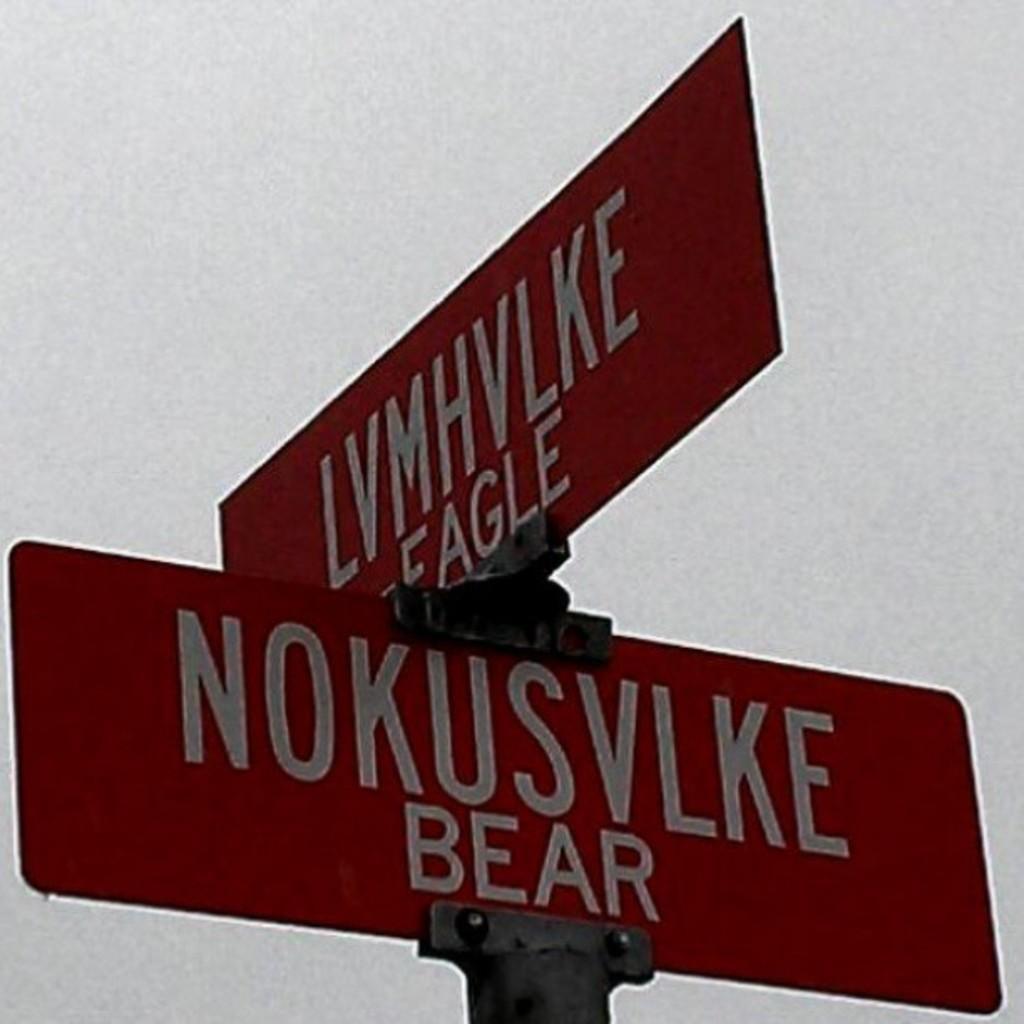Can you describe this image briefly? In this image we can see two boards with some text. There is a sky in the image. 